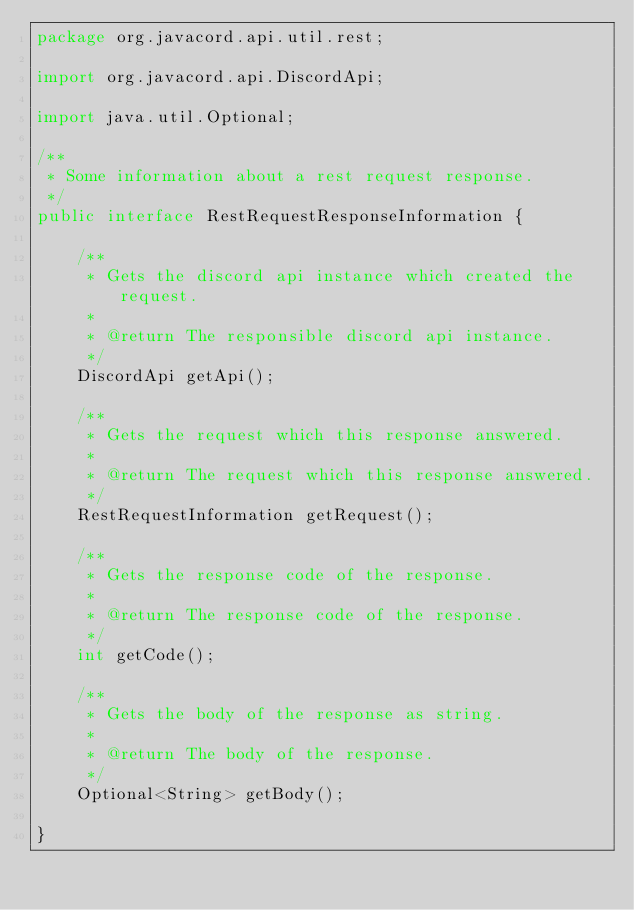Convert code to text. <code><loc_0><loc_0><loc_500><loc_500><_Java_>package org.javacord.api.util.rest;

import org.javacord.api.DiscordApi;

import java.util.Optional;

/**
 * Some information about a rest request response.
 */
public interface RestRequestResponseInformation {

    /**
     * Gets the discord api instance which created the request.
     *
     * @return The responsible discord api instance.
     */
    DiscordApi getApi();

    /**
     * Gets the request which this response answered.
     *
     * @return The request which this response answered.
     */
    RestRequestInformation getRequest();

    /**
     * Gets the response code of the response.
     *
     * @return The response code of the response.
     */
    int getCode();

    /**
     * Gets the body of the response as string.
     *
     * @return The body of the response.
     */
    Optional<String> getBody();

}
</code> 